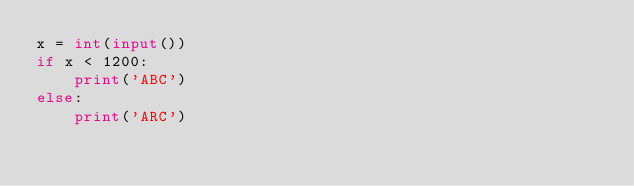<code> <loc_0><loc_0><loc_500><loc_500><_Python_>x = int(input())
if x < 1200:
    print('ABC')
else:
    print('ARC')
</code> 